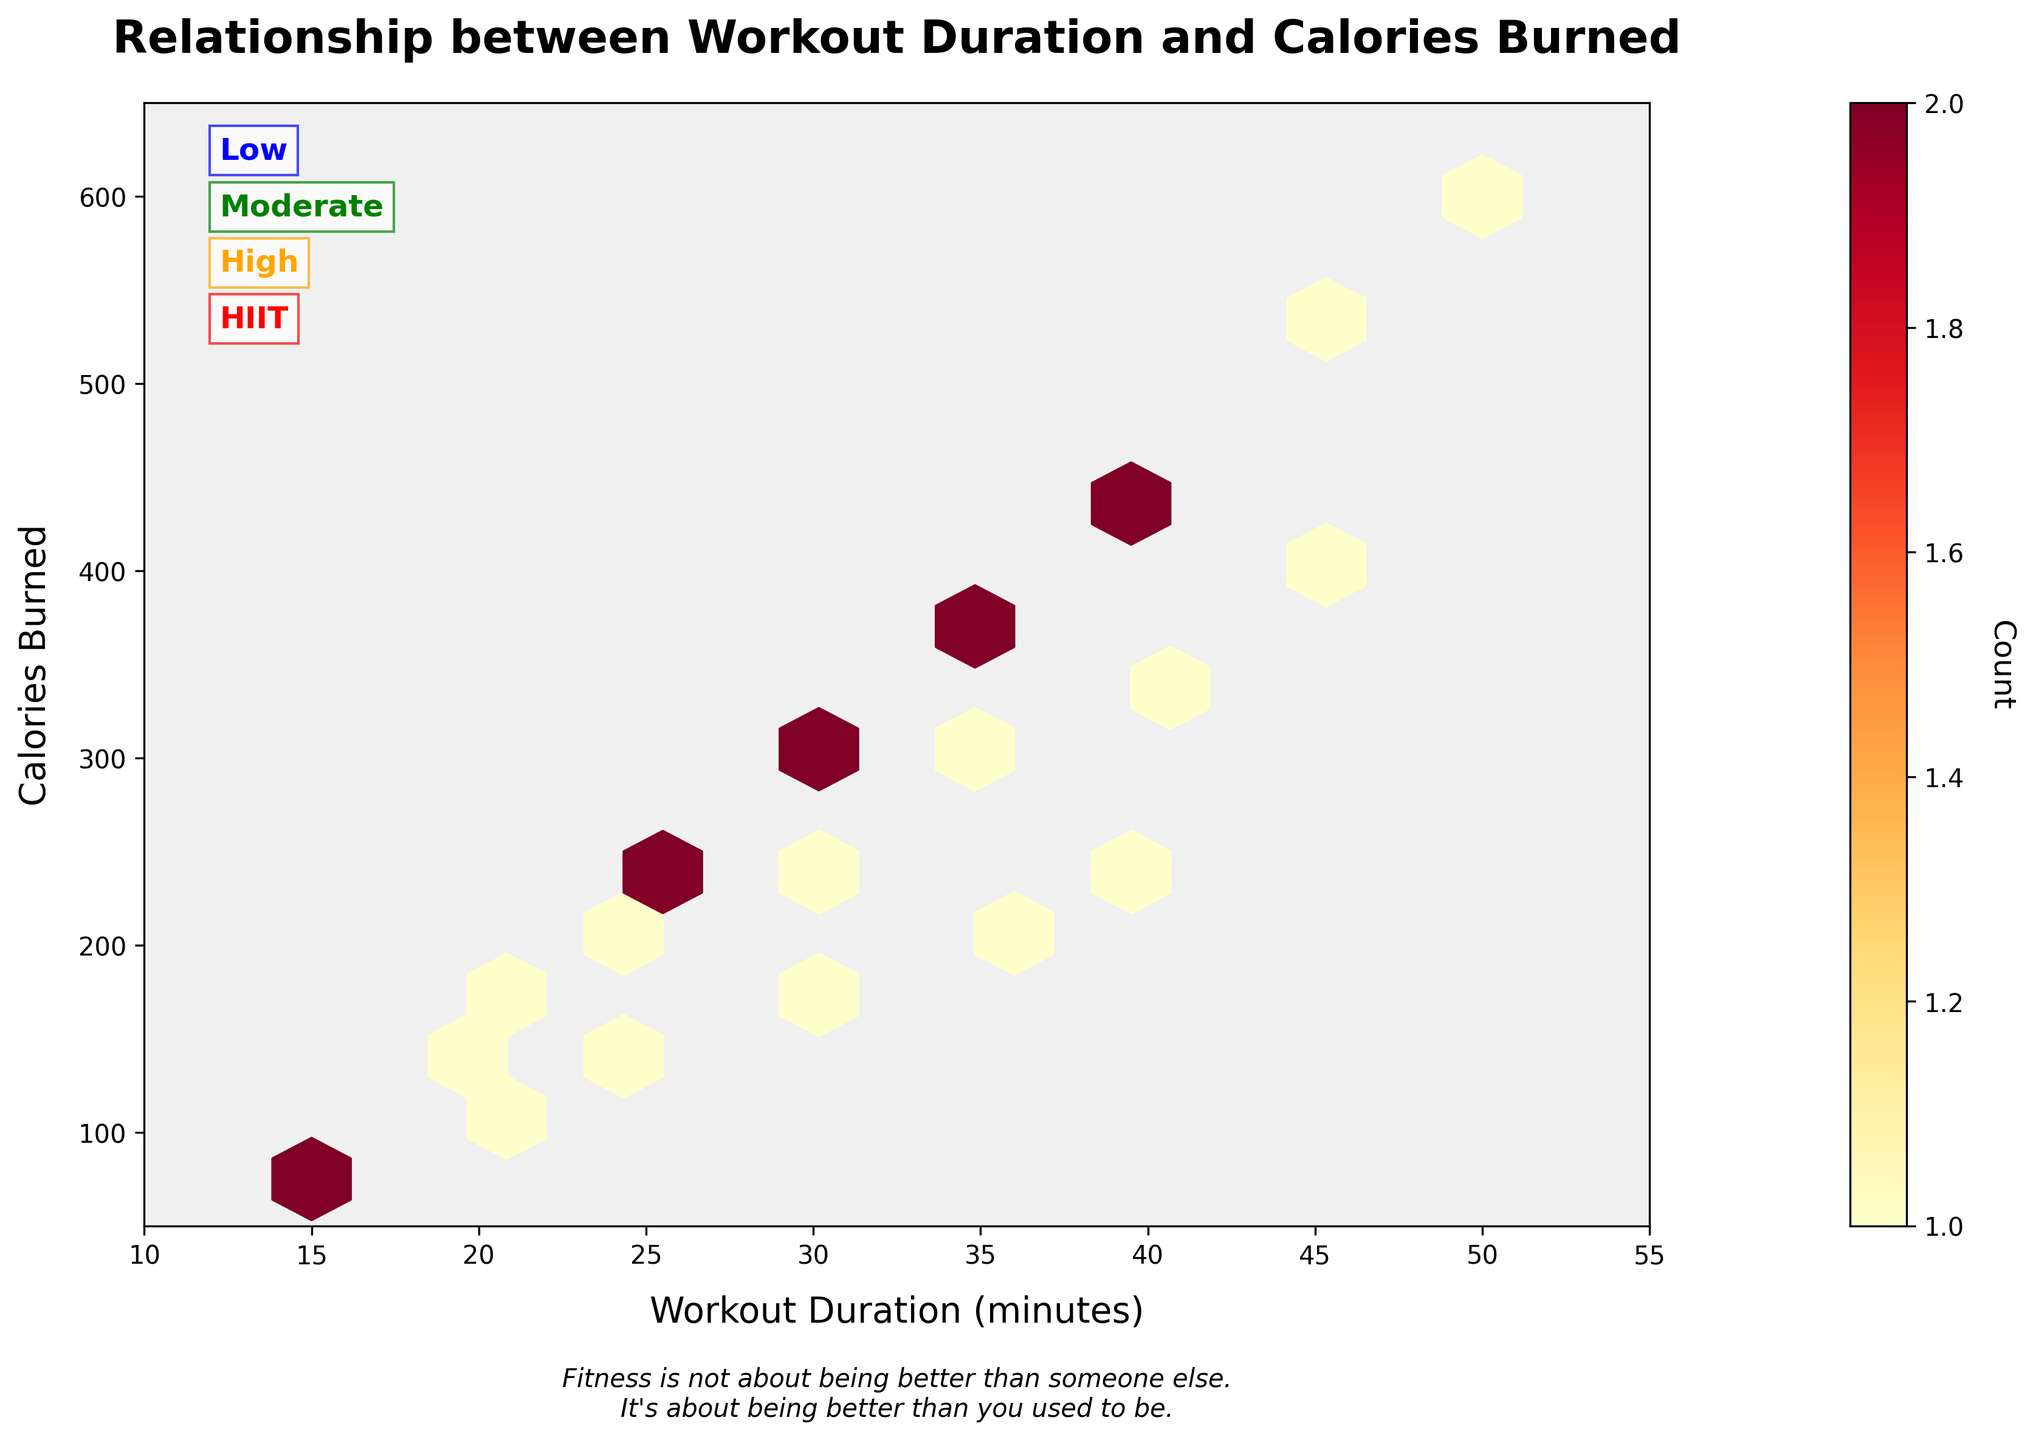What is the title of the figure? The title is displayed prominently above the plot area, typically in bold font
Answer: Relationship between Workout Duration and Calories Burned What do the colors in the hexagons represent? The colors of the hexagons indicate the count of data points in each bin, which is explained by the colorbar on the right side of the plot.
Answer: Count of data points How does the exercise intensity level vary across the figure? The intensity levels are annotated with their names ('Low', 'Moderate', 'High', 'HIIT') and colors (blue, green, orange, red) on the left side of the plot.
Answer: Low to HIIT from top to bottom What is the range of workout durations shown in the figure? The x-axis of the plot represents workout durations in minutes, with labeled ticks indicating the range. The axis starts at 10 minutes and ends at 55 minutes.
Answer: 10 to 55 minutes What is the relationship between workout duration and calories burned? Observing the overall pattern, the hexagons plot shows a positive correlation where longer workout durations are generally associated with higher calories burned, regardless of intensity.
Answer: Positive correlation Which intensity level has the highest calorie count for a 40-minute workout? By observing the hexagons and annotations, for a 40-minute workout, the highest calorie burned is seen in the 'High' and 'HIIT' intensity levels, where the color intensifies at higher counts.
Answer: High and HIIT Between 'Moderate' and 'High' intensity levels, which has a denser cluster of data points? By comparing the color intensity and the concentration of hexagons, the 'Moderate' intensity level shows a denser cluster than 'High'. This can be inferred through the color shading in the respective segments.
Answer: Moderate What can be inferred from the color of the hexagons in the 'Low' intensity level compared to others? The 'Low' intensity level hexagons are lighter in color compared to 'Moderate', 'High', and 'HIIT', indicating fewer data points in those bins.
Answer: Fewer data points When looking at the overall counts, which duration range sees the highest frequency of workout sessions? By observing the spread and color density of hexagons across the x-axis, the duration range of 25 to 35 minutes appears the most dense.
Answer: 25 to 35 minutes Explain the significance of the quote added to the figure. The quote at the bottom highlights the importance of personal progress in fitness, aligning with the aim of interpreting workout data to improve health. It adds motivational context beyond the data visualization.
Answer: Personal progress in fitness 